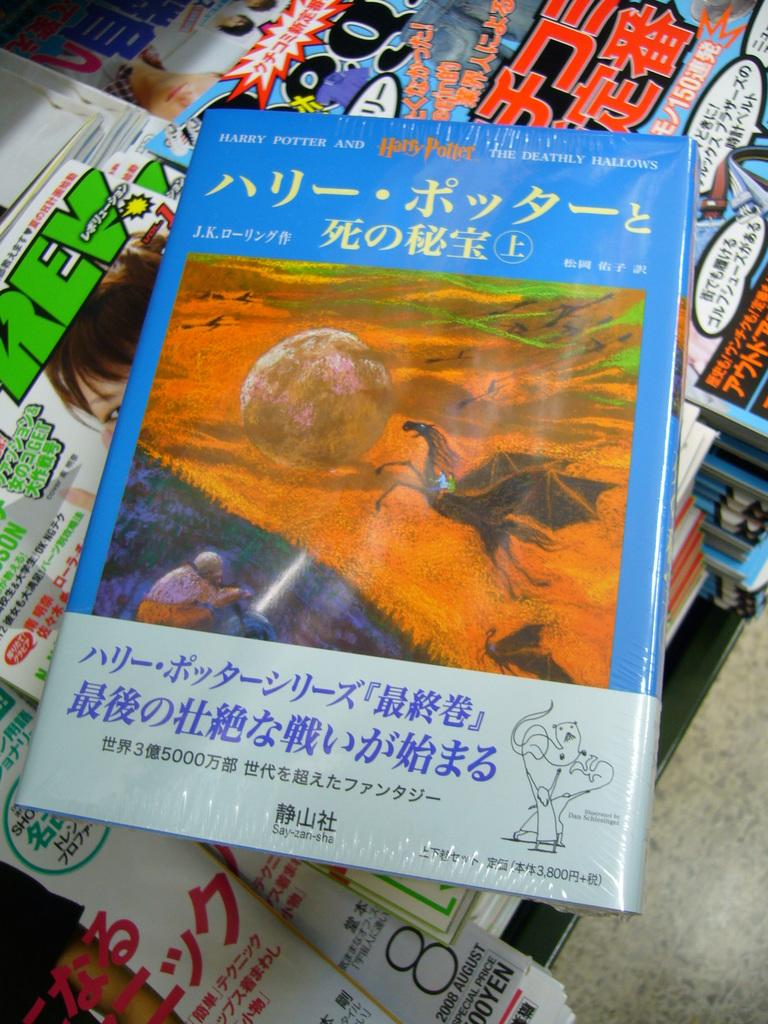<image>
Give a short and clear explanation of the subsequent image. A Harry Potter and the Deathly Hollow book written in Chinese sits on top of magazines and newspapers 